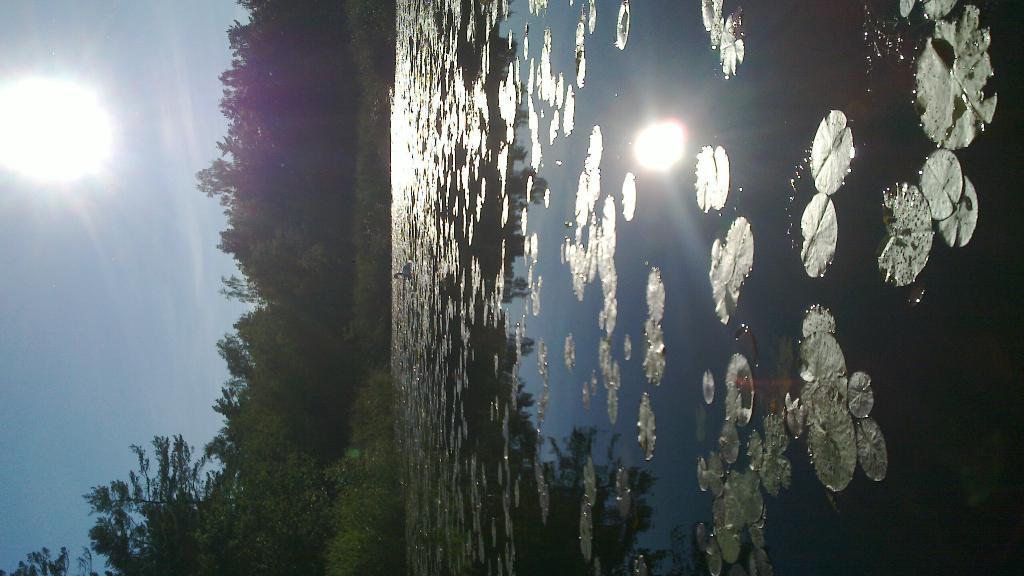In one or two sentences, can you explain what this image depicts? This picture is in left side direction. There are trees. At the top there is sky and there is sun. At the bottom there is water and there are leaves and there is a swan on the water. There is reflection of sky, sun and trees on the water. 